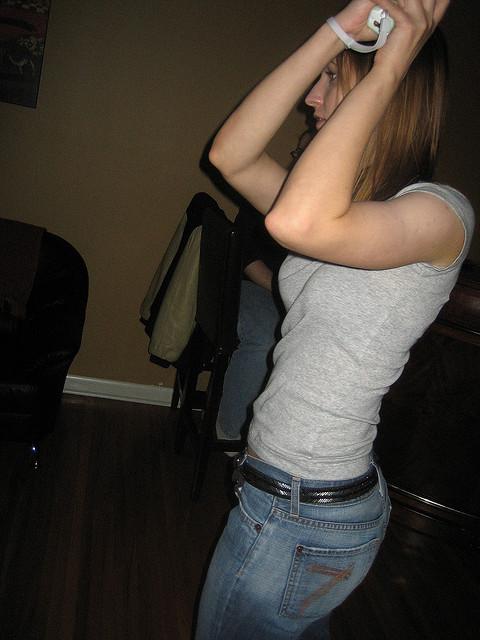Is she dancing?
Answer briefly. No. What are the people holding?
Give a very brief answer. Controller. What color is her top?
Answer briefly. Gray. Where is the woman holding herself?
Write a very short answer. Nowhere. What type of flooring is in the picture?
Give a very brief answer. Wood. How many thumbs are visible?
Quick response, please. 0. What is draped over the back of the chair?
Be succinct. Jacket. Does this person have any tattoos?
Answer briefly. No. What room is this in?
Keep it brief. Living room. Are the girls shirt and pants the same color?
Write a very short answer. No. How many people are there?
Short answer required. 1. What color is the wall?
Short answer required. Tan. Is the girl having fun?
Concise answer only. Yes. Is this person wearing long pants?
Keep it brief. Yes. 